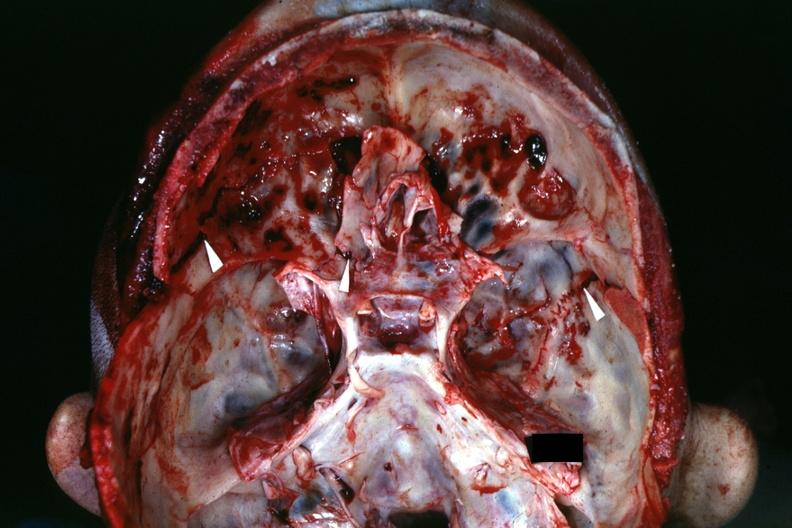what is present?
Answer the question using a single word or phrase. Basilar skull fracture 